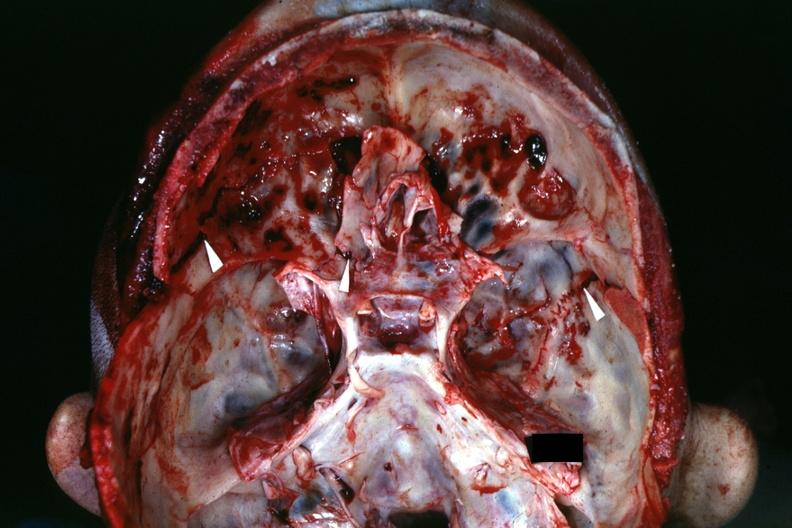what is present?
Answer the question using a single word or phrase. Basilar skull fracture 